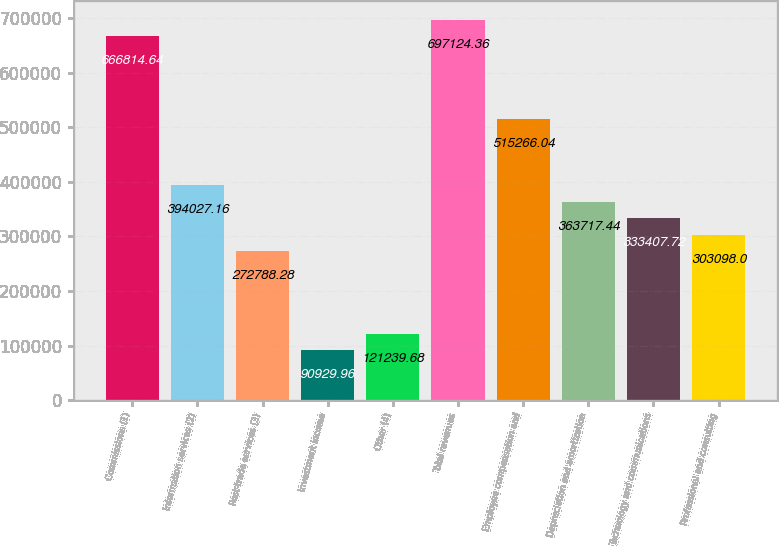Convert chart. <chart><loc_0><loc_0><loc_500><loc_500><bar_chart><fcel>Commissions (1)<fcel>Information services (2)<fcel>Post-trade services (3)<fcel>Investment income<fcel>Other (4)<fcel>Total revenues<fcel>Employee compensation and<fcel>Depreciation and amortization<fcel>Technology and communications<fcel>Professional and consulting<nl><fcel>666815<fcel>394027<fcel>272788<fcel>90930<fcel>121240<fcel>697124<fcel>515266<fcel>363717<fcel>333408<fcel>303098<nl></chart> 